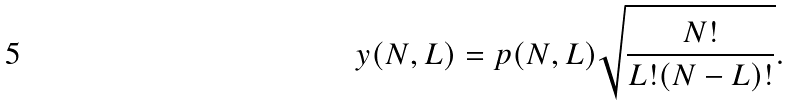<formula> <loc_0><loc_0><loc_500><loc_500>y ( N , L ) = p ( N , L ) \sqrt { \frac { N ! } { L ! ( N - L ) ! } } .</formula> 